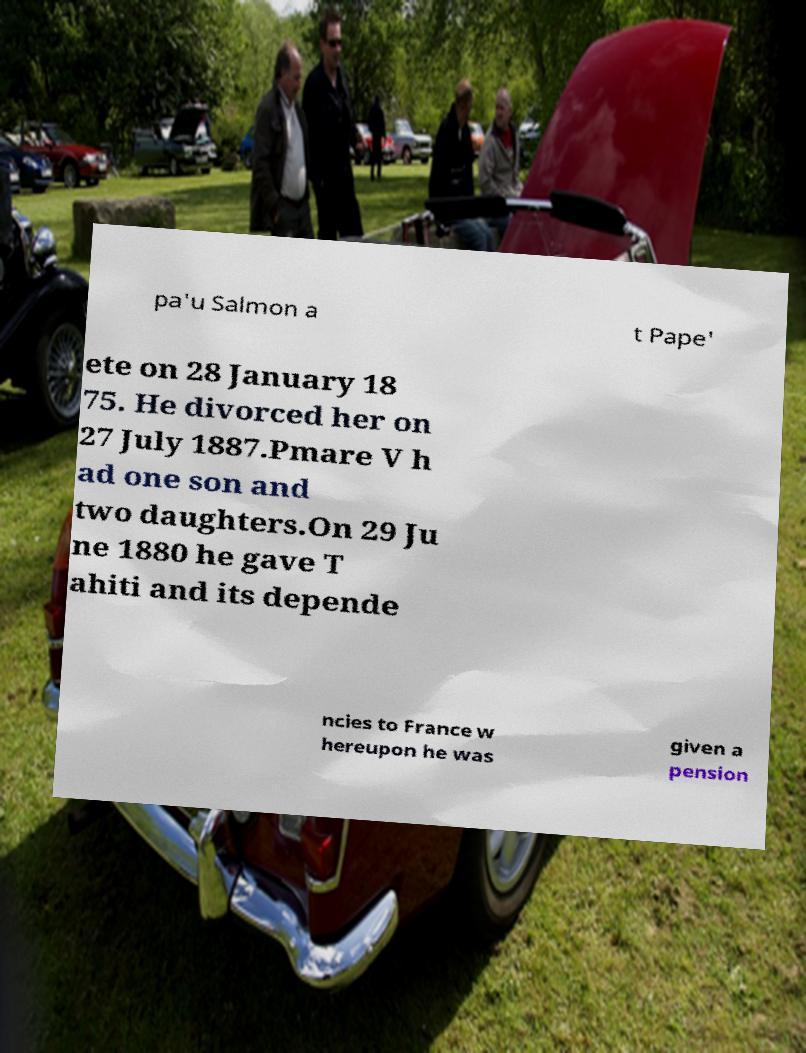Can you accurately transcribe the text from the provided image for me? pa'u Salmon a t Pape' ete on 28 January 18 75. He divorced her on 27 July 1887.Pmare V h ad one son and two daughters.On 29 Ju ne 1880 he gave T ahiti and its depende ncies to France w hereupon he was given a pension 